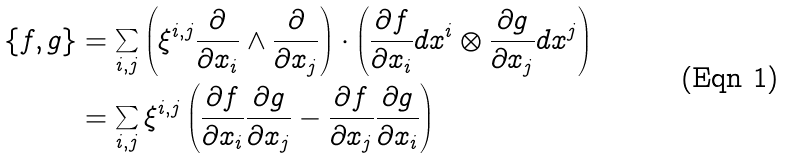<formula> <loc_0><loc_0><loc_500><loc_500>\{ f , g \} & = \sum _ { i , j } \left ( \xi ^ { i , j } \frac { \partial } { \partial x _ { i } } \wedge \frac { \partial } { \partial x _ { j } } \right ) \cdot \left ( \frac { \partial f } { \partial x _ { i } } d x ^ { i } \otimes \frac { \partial g } { \partial x _ { j } } d x ^ { j } \right ) \\ & = \sum _ { i , j } \xi ^ { i , j } \left ( \frac { \partial f } { \partial x _ { i } } \frac { \partial g } { \partial x _ { j } } - \frac { \partial f } { \partial x _ { j } } \frac { \partial g } { \partial x _ { i } } \right )</formula> 